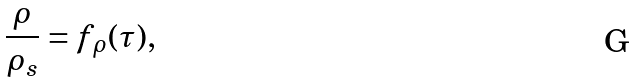Convert formula to latex. <formula><loc_0><loc_0><loc_500><loc_500>\frac { \rho } { \rho _ { s } } = f _ { \rho } ( \tau ) ,</formula> 